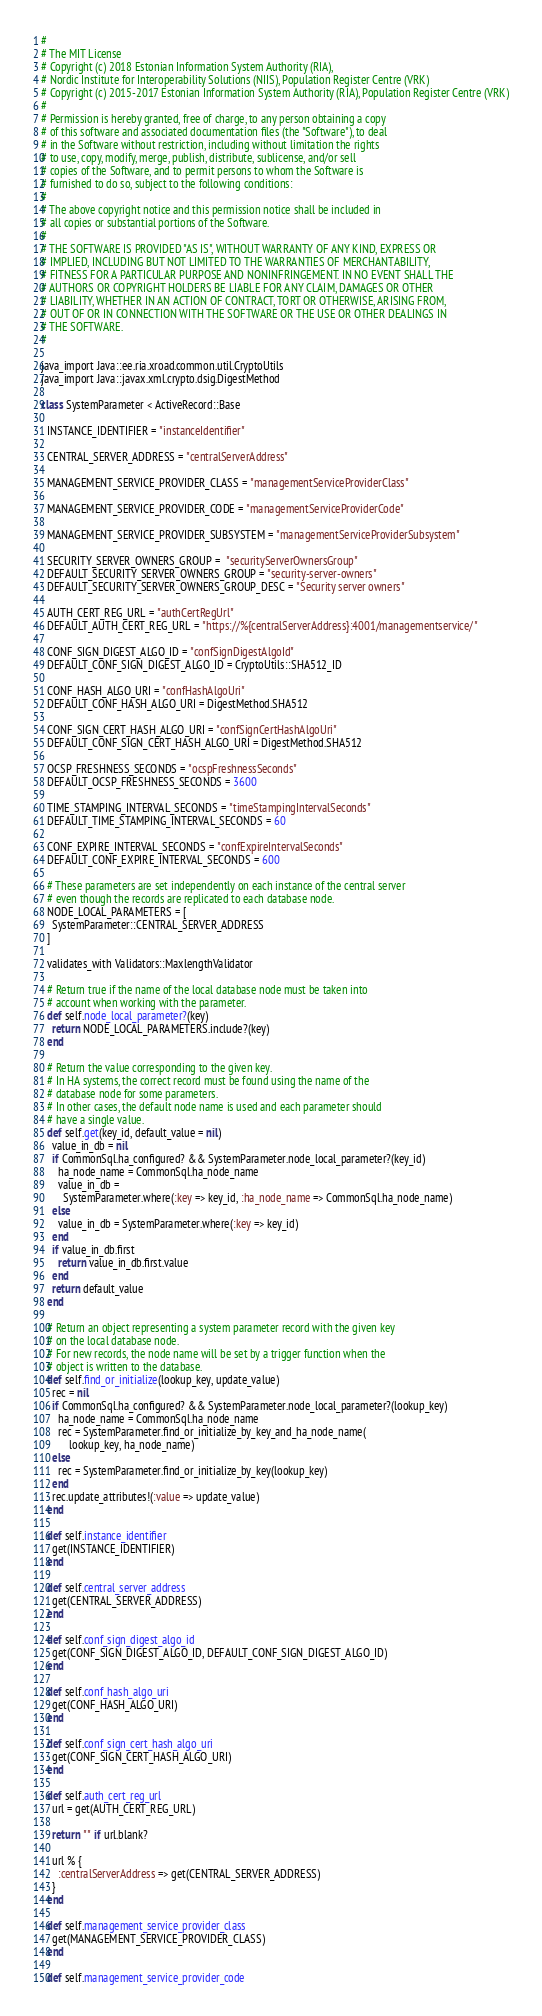Convert code to text. <code><loc_0><loc_0><loc_500><loc_500><_Ruby_>#
# The MIT License
# Copyright (c) 2018 Estonian Information System Authority (RIA),
# Nordic Institute for Interoperability Solutions (NIIS), Population Register Centre (VRK)
# Copyright (c) 2015-2017 Estonian Information System Authority (RIA), Population Register Centre (VRK)
#
# Permission is hereby granted, free of charge, to any person obtaining a copy
# of this software and associated documentation files (the "Software"), to deal
# in the Software without restriction, including without limitation the rights
# to use, copy, modify, merge, publish, distribute, sublicense, and/or sell
# copies of the Software, and to permit persons to whom the Software is
# furnished to do so, subject to the following conditions:
#
# The above copyright notice and this permission notice shall be included in
# all copies or substantial portions of the Software.
#
# THE SOFTWARE IS PROVIDED "AS IS", WITHOUT WARRANTY OF ANY KIND, EXPRESS OR
# IMPLIED, INCLUDING BUT NOT LIMITED TO THE WARRANTIES OF MERCHANTABILITY,
# FITNESS FOR A PARTICULAR PURPOSE AND NONINFRINGEMENT. IN NO EVENT SHALL THE
# AUTHORS OR COPYRIGHT HOLDERS BE LIABLE FOR ANY CLAIM, DAMAGES OR OTHER
# LIABILITY, WHETHER IN AN ACTION OF CONTRACT, TORT OR OTHERWISE, ARISING FROM,
# OUT OF OR IN CONNECTION WITH THE SOFTWARE OR THE USE OR OTHER DEALINGS IN
# THE SOFTWARE.
#

java_import Java::ee.ria.xroad.common.util.CryptoUtils
java_import Java::javax.xml.crypto.dsig.DigestMethod

class SystemParameter < ActiveRecord::Base

  INSTANCE_IDENTIFIER = "instanceIdentifier"

  CENTRAL_SERVER_ADDRESS = "centralServerAddress"

  MANAGEMENT_SERVICE_PROVIDER_CLASS = "managementServiceProviderClass"

  MANAGEMENT_SERVICE_PROVIDER_CODE = "managementServiceProviderCode"

  MANAGEMENT_SERVICE_PROVIDER_SUBSYSTEM = "managementServiceProviderSubsystem"

  SECURITY_SERVER_OWNERS_GROUP =  "securityServerOwnersGroup"
  DEFAULT_SECURITY_SERVER_OWNERS_GROUP = "security-server-owners"
  DEFAULT_SECURITY_SERVER_OWNERS_GROUP_DESC = "Security server owners"

  AUTH_CERT_REG_URL = "authCertRegUrl"
  DEFAULT_AUTH_CERT_REG_URL = "https://%{centralServerAddress}:4001/managementservice/"

  CONF_SIGN_DIGEST_ALGO_ID = "confSignDigestAlgoId"
  DEFAULT_CONF_SIGN_DIGEST_ALGO_ID = CryptoUtils::SHA512_ID

  CONF_HASH_ALGO_URI = "confHashAlgoUri"
  DEFAULT_CONF_HASH_ALGO_URI = DigestMethod.SHA512

  CONF_SIGN_CERT_HASH_ALGO_URI = "confSignCertHashAlgoUri"
  DEFAULT_CONF_SIGN_CERT_HASH_ALGO_URI = DigestMethod.SHA512

  OCSP_FRESHNESS_SECONDS = "ocspFreshnessSeconds"
  DEFAULT_OCSP_FRESHNESS_SECONDS = 3600

  TIME_STAMPING_INTERVAL_SECONDS = "timeStampingIntervalSeconds"
  DEFAULT_TIME_STAMPING_INTERVAL_SECONDS = 60

  CONF_EXPIRE_INTERVAL_SECONDS = "confExpireIntervalSeconds"
  DEFAULT_CONF_EXPIRE_INTERVAL_SECONDS = 600

  # These parameters are set independently on each instance of the central server
  # even though the records are replicated to each database node.
  NODE_LOCAL_PARAMETERS = [
    SystemParameter::CENTRAL_SERVER_ADDRESS
  ]

  validates_with Validators::MaxlengthValidator

  # Return true if the name of the local database node must be taken into
  # account when working with the parameter.
  def self.node_local_parameter?(key)
    return NODE_LOCAL_PARAMETERS.include?(key)
  end

  # Return the value corresponding to the given key.
  # In HA systems, the correct record must be found using the name of the
  # database node for some parameters.
  # In other cases, the default node name is used and each parameter should
  # have a single value.
  def self.get(key_id, default_value = nil)
    value_in_db = nil
    if CommonSql.ha_configured? && SystemParameter.node_local_parameter?(key_id)
      ha_node_name = CommonSql.ha_node_name
      value_in_db =
        SystemParameter.where(:key => key_id, :ha_node_name => CommonSql.ha_node_name)
    else
      value_in_db = SystemParameter.where(:key => key_id)
    end
    if value_in_db.first
      return value_in_db.first.value
    end
    return default_value
  end

  # Return an object representing a system parameter record with the given key
  # on the local database node.
  # For new records, the node name will be set by a trigger function when the
  # object is written to the database.
  def self.find_or_initialize(lookup_key, update_value)
    rec = nil
    if CommonSql.ha_configured? && SystemParameter.node_local_parameter?(lookup_key)
      ha_node_name = CommonSql.ha_node_name
      rec = SystemParameter.find_or_initialize_by_key_and_ha_node_name(
          lookup_key, ha_node_name)
    else
      rec = SystemParameter.find_or_initialize_by_key(lookup_key)
    end
    rec.update_attributes!(:value => update_value)
  end

  def self.instance_identifier
    get(INSTANCE_IDENTIFIER)
  end

  def self.central_server_address
    get(CENTRAL_SERVER_ADDRESS)
  end

  def self.conf_sign_digest_algo_id
    get(CONF_SIGN_DIGEST_ALGO_ID, DEFAULT_CONF_SIGN_DIGEST_ALGO_ID)
  end

  def self.conf_hash_algo_uri
    get(CONF_HASH_ALGO_URI)
  end

  def self.conf_sign_cert_hash_algo_uri
    get(CONF_SIGN_CERT_HASH_ALGO_URI)
  end

  def self.auth_cert_reg_url
    url = get(AUTH_CERT_REG_URL)

    return "" if url.blank?

    url % {
      :centralServerAddress => get(CENTRAL_SERVER_ADDRESS)
    }
  end

  def self.management_service_provider_class
    get(MANAGEMENT_SERVICE_PROVIDER_CLASS)
  end

  def self.management_service_provider_code</code> 